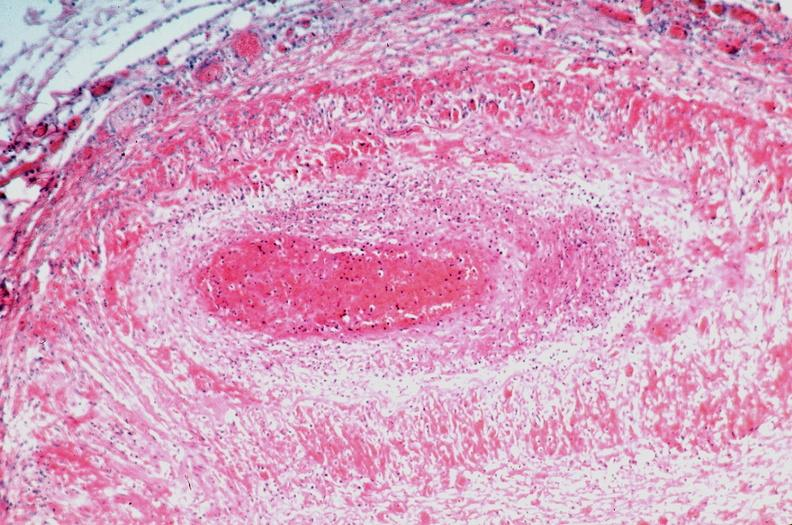where is this from?
Answer the question using a single word or phrase. Vasculature 